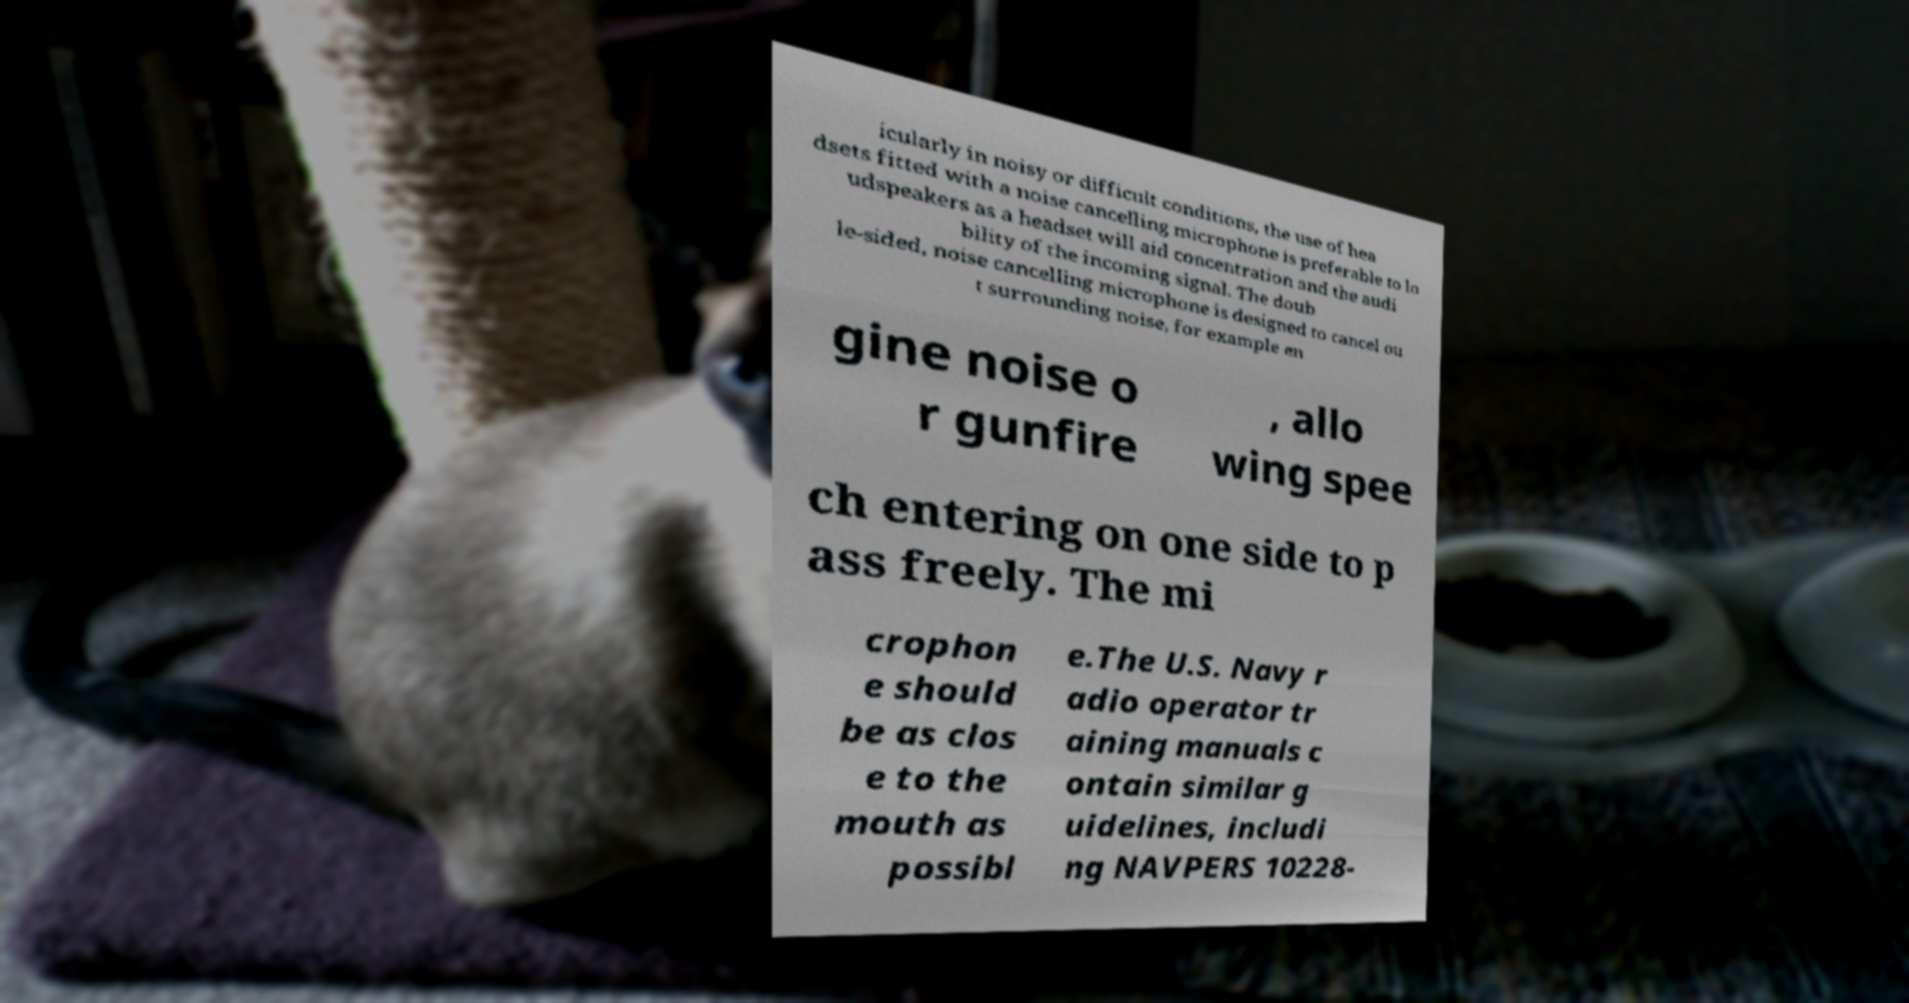Can you accurately transcribe the text from the provided image for me? icularly in noisy or difficult conditions, the use of hea dsets fitted with a noise cancelling microphone is preferable to lo udspeakers as a headset will aid concentration and the audi bility of the incoming signal. The doub le-sided, noise cancelling microphone is designed to cancel ou t surrounding noise, for example en gine noise o r gunfire , allo wing spee ch entering on one side to p ass freely. The mi crophon e should be as clos e to the mouth as possibl e.The U.S. Navy r adio operator tr aining manuals c ontain similar g uidelines, includi ng NAVPERS 10228- 